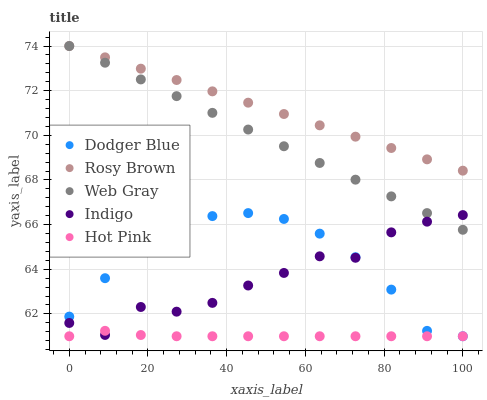Does Hot Pink have the minimum area under the curve?
Answer yes or no. Yes. Does Rosy Brown have the maximum area under the curve?
Answer yes or no. Yes. Does Indigo have the minimum area under the curve?
Answer yes or no. No. Does Indigo have the maximum area under the curve?
Answer yes or no. No. Is Web Gray the smoothest?
Answer yes or no. Yes. Is Indigo the roughest?
Answer yes or no. Yes. Is Rosy Brown the smoothest?
Answer yes or no. No. Is Rosy Brown the roughest?
Answer yes or no. No. Does Dodger Blue have the lowest value?
Answer yes or no. Yes. Does Indigo have the lowest value?
Answer yes or no. No. Does Rosy Brown have the highest value?
Answer yes or no. Yes. Does Indigo have the highest value?
Answer yes or no. No. Is Dodger Blue less than Rosy Brown?
Answer yes or no. Yes. Is Rosy Brown greater than Indigo?
Answer yes or no. Yes. Does Rosy Brown intersect Web Gray?
Answer yes or no. Yes. Is Rosy Brown less than Web Gray?
Answer yes or no. No. Is Rosy Brown greater than Web Gray?
Answer yes or no. No. Does Dodger Blue intersect Rosy Brown?
Answer yes or no. No. 